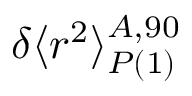<formula> <loc_0><loc_0><loc_500><loc_500>\delta \langle r ^ { 2 } \rangle _ { P ( 1 ) } ^ { A , 9 0 }</formula> 